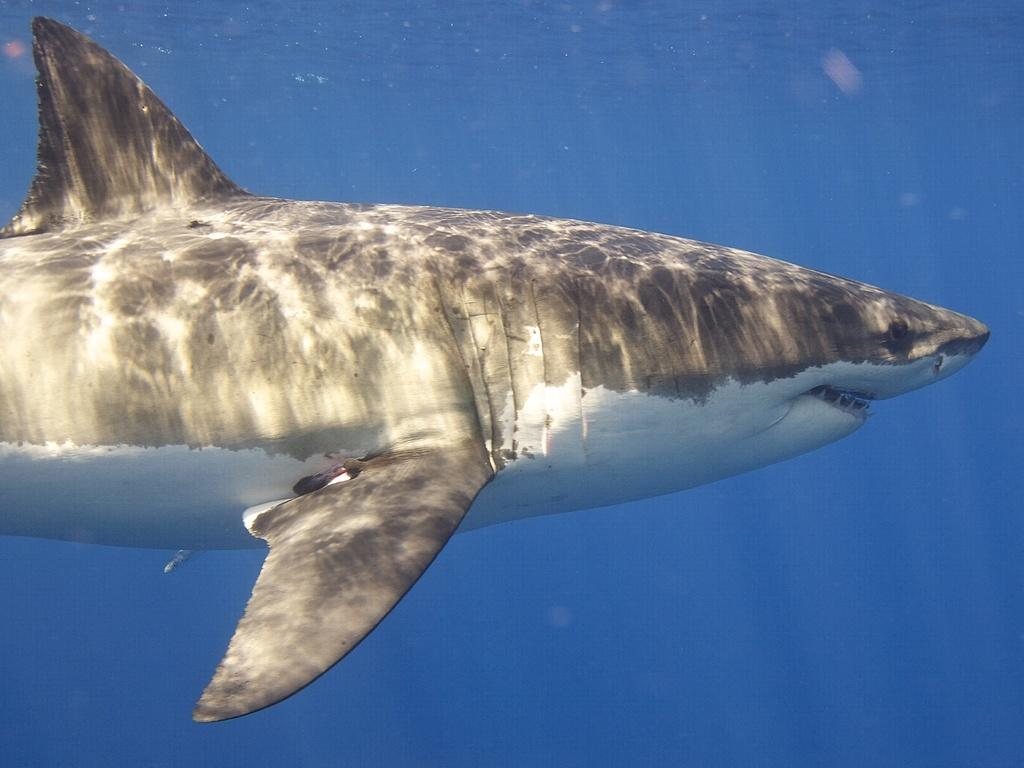What is the main subject of the image? The main subject of the image is a shark. What is the shark doing in the image? The shark is swimming in the water. How is the shark positioned in the image? The shark is truncated towards the left side of the image. What color is the background of the image? The background of the image is blue in color. What scent can be detected in the image? There is no mention of any scent in the image, as it primarily features a shark swimming in water. 